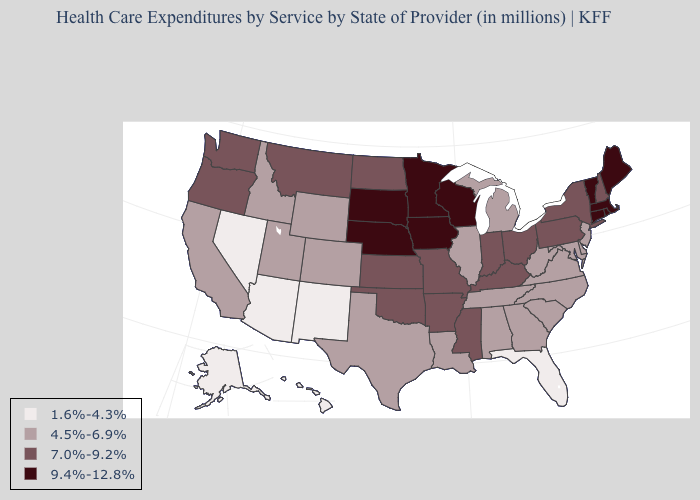Name the states that have a value in the range 1.6%-4.3%?
Quick response, please. Alaska, Arizona, Florida, Hawaii, Nevada, New Mexico. Among the states that border Virginia , does Kentucky have the highest value?
Quick response, please. Yes. Name the states that have a value in the range 7.0%-9.2%?
Give a very brief answer. Arkansas, Indiana, Kansas, Kentucky, Mississippi, Missouri, Montana, New Hampshire, New York, North Dakota, Ohio, Oklahoma, Oregon, Pennsylvania, Washington. Among the states that border Idaho , which have the highest value?
Be succinct. Montana, Oregon, Washington. Name the states that have a value in the range 4.5%-6.9%?
Quick response, please. Alabama, California, Colorado, Delaware, Georgia, Idaho, Illinois, Louisiana, Maryland, Michigan, New Jersey, North Carolina, South Carolina, Tennessee, Texas, Utah, Virginia, West Virginia, Wyoming. What is the lowest value in the MidWest?
Answer briefly. 4.5%-6.9%. Does the first symbol in the legend represent the smallest category?
Quick response, please. Yes. What is the highest value in the USA?
Keep it brief. 9.4%-12.8%. Name the states that have a value in the range 1.6%-4.3%?
Answer briefly. Alaska, Arizona, Florida, Hawaii, Nevada, New Mexico. What is the value of Indiana?
Keep it brief. 7.0%-9.2%. Which states hav the highest value in the MidWest?
Write a very short answer. Iowa, Minnesota, Nebraska, South Dakota, Wisconsin. What is the value of West Virginia?
Keep it brief. 4.5%-6.9%. Name the states that have a value in the range 1.6%-4.3%?
Quick response, please. Alaska, Arizona, Florida, Hawaii, Nevada, New Mexico. Does the first symbol in the legend represent the smallest category?
Keep it brief. Yes. Name the states that have a value in the range 4.5%-6.9%?
Write a very short answer. Alabama, California, Colorado, Delaware, Georgia, Idaho, Illinois, Louisiana, Maryland, Michigan, New Jersey, North Carolina, South Carolina, Tennessee, Texas, Utah, Virginia, West Virginia, Wyoming. 